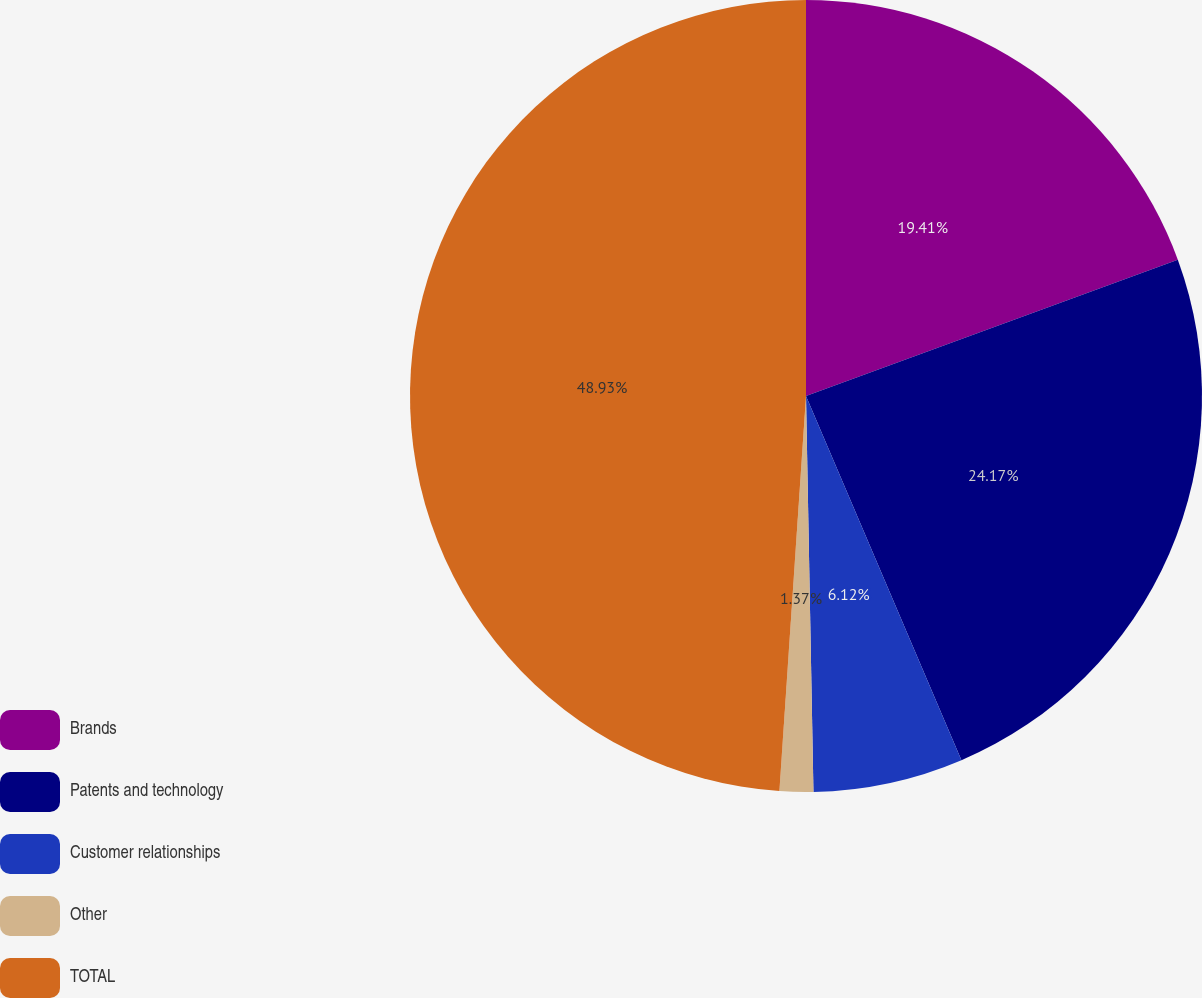<chart> <loc_0><loc_0><loc_500><loc_500><pie_chart><fcel>Brands<fcel>Patents and technology<fcel>Customer relationships<fcel>Other<fcel>TOTAL<nl><fcel>19.41%<fcel>24.17%<fcel>6.12%<fcel>1.37%<fcel>48.93%<nl></chart> 